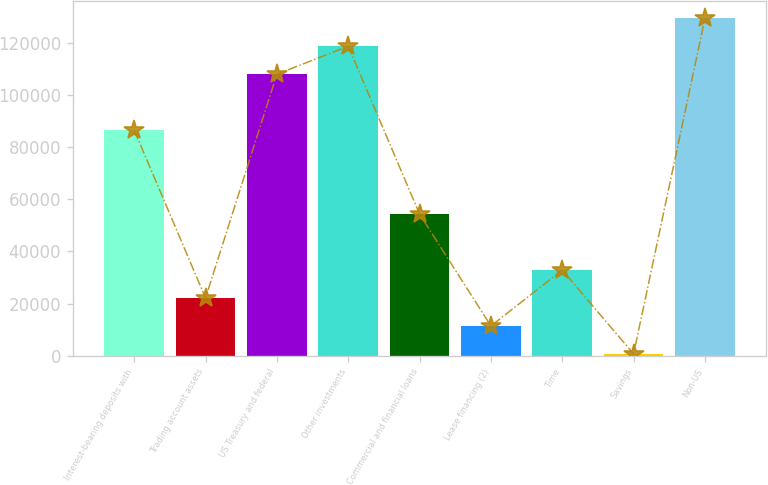<chart> <loc_0><loc_0><loc_500><loc_500><bar_chart><fcel>Interest-bearing deposits with<fcel>Trading account assets<fcel>US Treasury and federal<fcel>Other investments<fcel>Commercial and financial loans<fcel>Lease financing (2)<fcel>Time<fcel>Savings<fcel>Non-US<nl><fcel>86510.2<fcel>22160.8<fcel>107960<fcel>118685<fcel>54335.5<fcel>11435.9<fcel>32885.7<fcel>711<fcel>129410<nl></chart> 